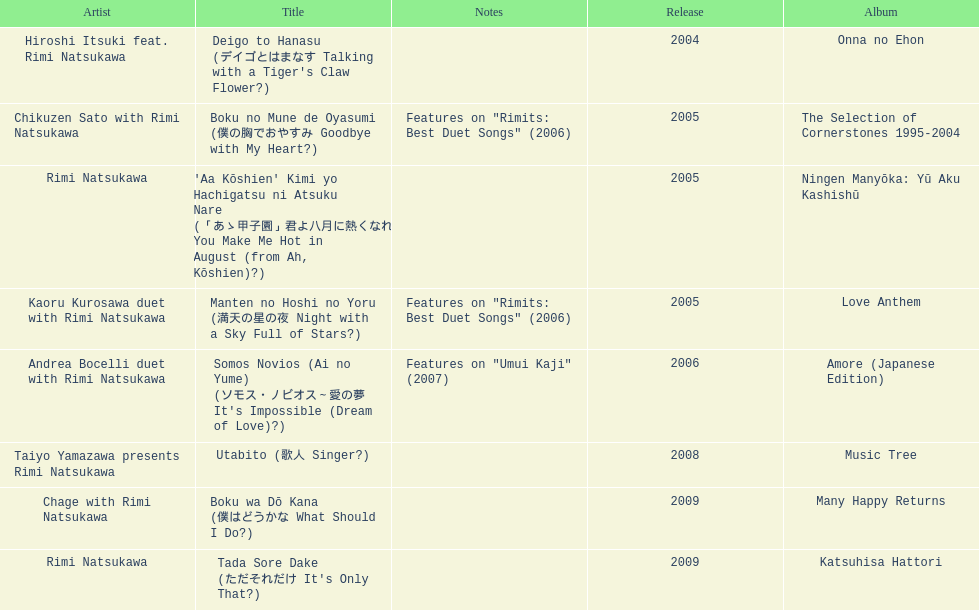Which year had the most titles released? 2005. 